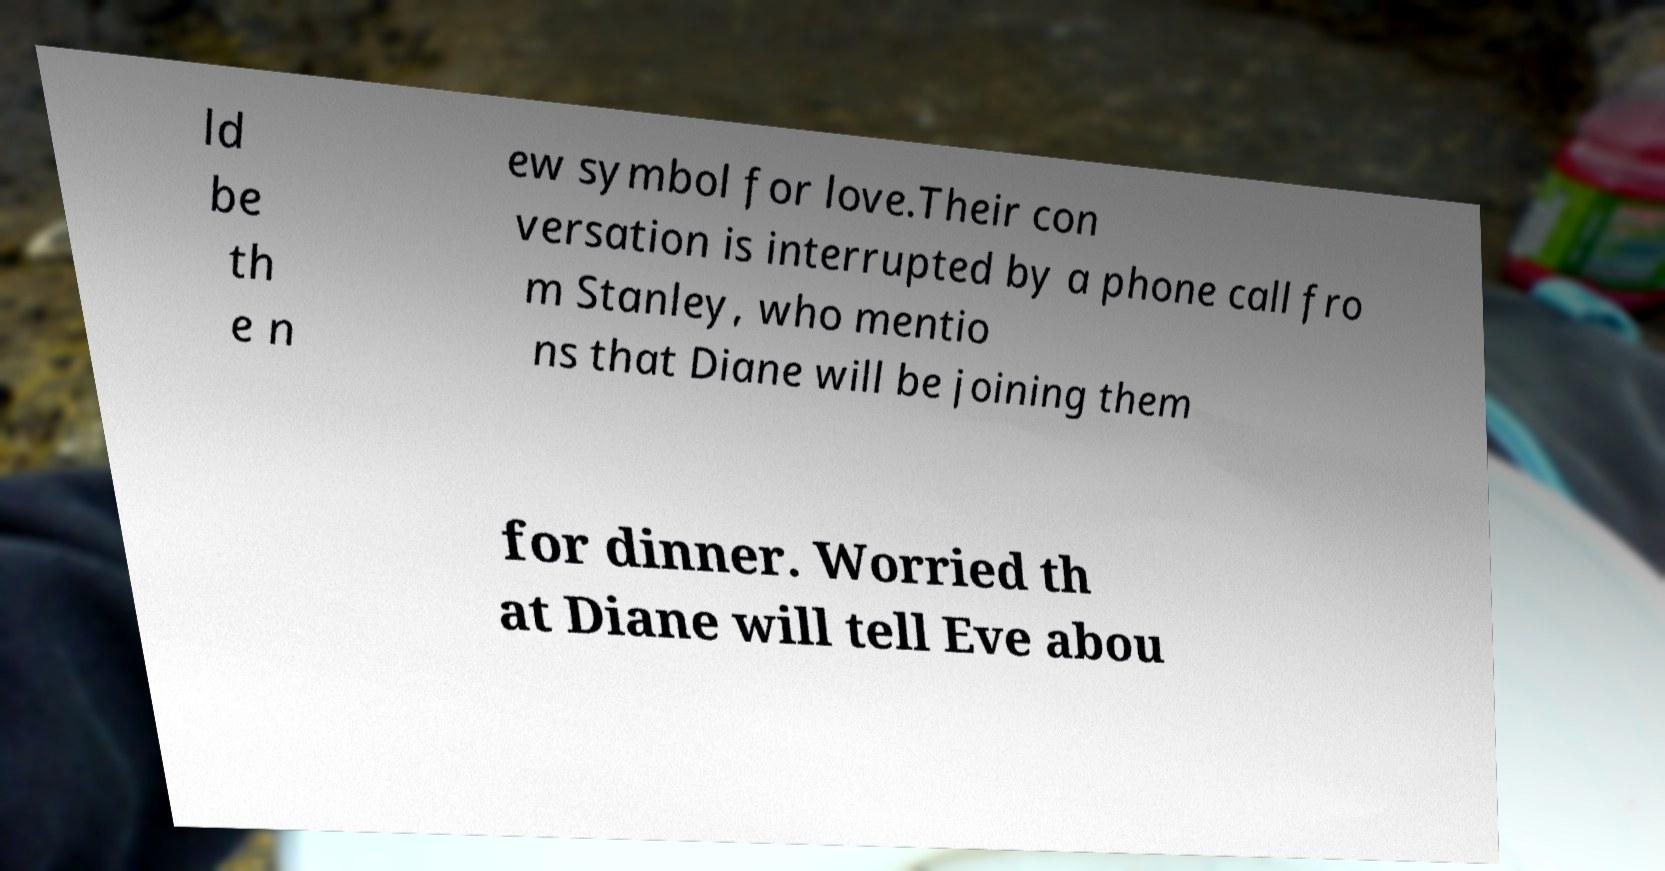For documentation purposes, I need the text within this image transcribed. Could you provide that? ld be th e n ew symbol for love.Their con versation is interrupted by a phone call fro m Stanley, who mentio ns that Diane will be joining them for dinner. Worried th at Diane will tell Eve abou 